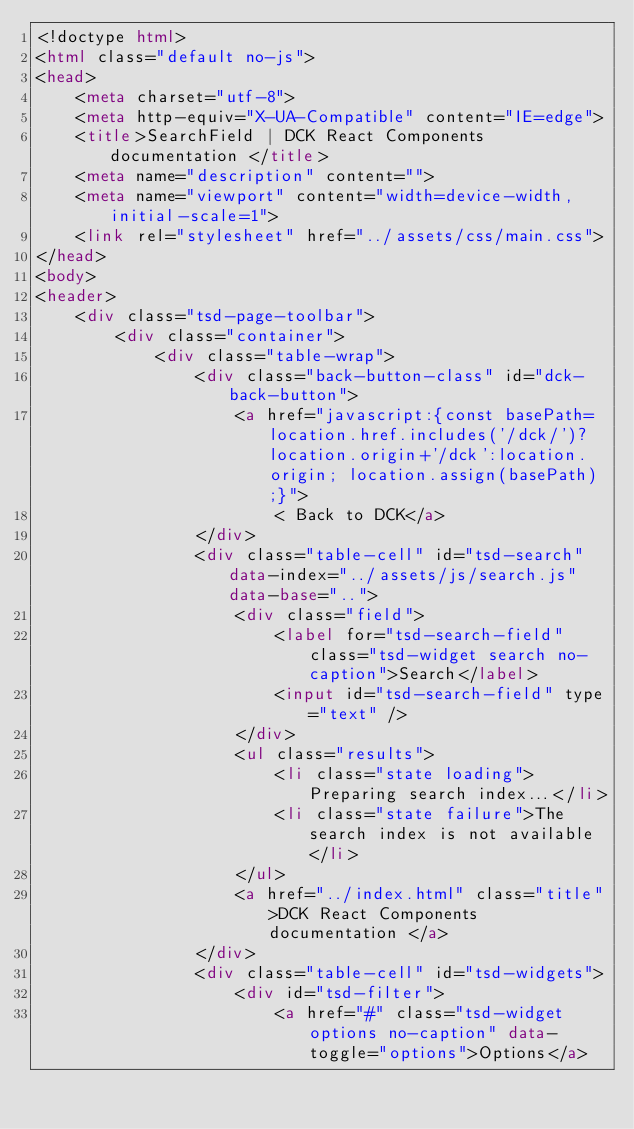Convert code to text. <code><loc_0><loc_0><loc_500><loc_500><_HTML_><!doctype html>
<html class="default no-js">
<head>
	<meta charset="utf-8">
	<meta http-equiv="X-UA-Compatible" content="IE=edge">
	<title>SearchField | DCK React Components documentation </title>
	<meta name="description" content="">
	<meta name="viewport" content="width=device-width, initial-scale=1">
	<link rel="stylesheet" href="../assets/css/main.css">
</head>
<body>
<header>
	<div class="tsd-page-toolbar">
		<div class="container">
			<div class="table-wrap">
				<div class="back-button-class" id="dck-back-button">
					<a href="javascript:{const basePath=location.href.includes('/dck/')?location.origin+'/dck':location.origin; location.assign(basePath);}">
						< Back to DCK</a>
				</div>
				<div class="table-cell" id="tsd-search" data-index="../assets/js/search.js" data-base="..">
					<div class="field">
						<label for="tsd-search-field" class="tsd-widget search no-caption">Search</label>
						<input id="tsd-search-field" type="text" />
					</div>
					<ul class="results">
						<li class="state loading">Preparing search index...</li>
						<li class="state failure">The search index is not available</li>
					</ul>
					<a href="../index.html" class="title">DCK React Components documentation </a>
				</div>
				<div class="table-cell" id="tsd-widgets">
					<div id="tsd-filter">
						<a href="#" class="tsd-widget options no-caption" data-toggle="options">Options</a></code> 